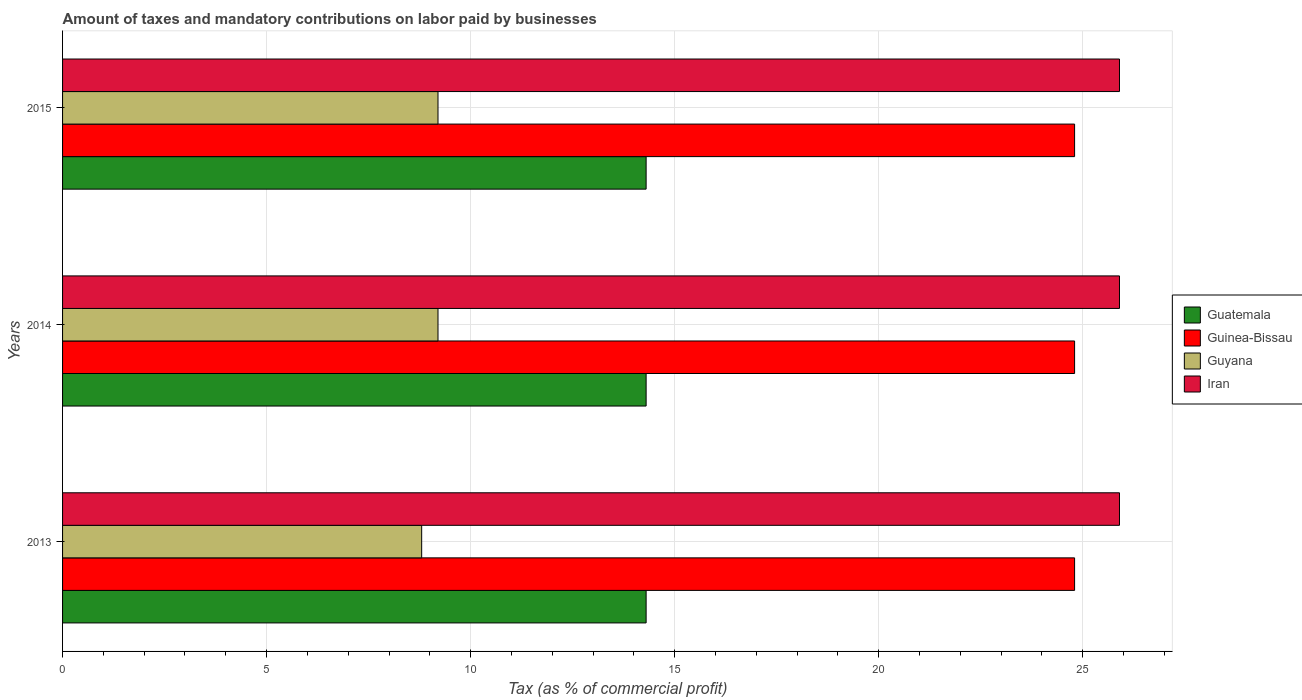Are the number of bars per tick equal to the number of legend labels?
Provide a succinct answer. Yes. How many bars are there on the 2nd tick from the top?
Ensure brevity in your answer.  4. What is the label of the 1st group of bars from the top?
Make the answer very short. 2015. Across all years, what is the maximum percentage of taxes paid by businesses in Guinea-Bissau?
Provide a succinct answer. 24.8. Across all years, what is the minimum percentage of taxes paid by businesses in Guinea-Bissau?
Offer a very short reply. 24.8. In which year was the percentage of taxes paid by businesses in Guyana minimum?
Make the answer very short. 2013. What is the total percentage of taxes paid by businesses in Iran in the graph?
Ensure brevity in your answer.  77.7. What is the difference between the percentage of taxes paid by businesses in Guinea-Bissau in 2014 and that in 2015?
Give a very brief answer. 0. What is the difference between the percentage of taxes paid by businesses in Guyana in 2013 and the percentage of taxes paid by businesses in Guinea-Bissau in 2015?
Make the answer very short. -16. What is the average percentage of taxes paid by businesses in Guinea-Bissau per year?
Your response must be concise. 24.8. In the year 2013, what is the difference between the percentage of taxes paid by businesses in Guatemala and percentage of taxes paid by businesses in Iran?
Your answer should be very brief. -11.6. What is the ratio of the percentage of taxes paid by businesses in Guyana in 2013 to that in 2014?
Keep it short and to the point. 0.96. Is the percentage of taxes paid by businesses in Guyana in 2013 less than that in 2014?
Provide a succinct answer. Yes. What is the difference between the highest and the second highest percentage of taxes paid by businesses in Guatemala?
Your answer should be very brief. 0. In how many years, is the percentage of taxes paid by businesses in Guinea-Bissau greater than the average percentage of taxes paid by businesses in Guinea-Bissau taken over all years?
Provide a short and direct response. 0. What does the 3rd bar from the top in 2013 represents?
Make the answer very short. Guinea-Bissau. What does the 3rd bar from the bottom in 2013 represents?
Provide a succinct answer. Guyana. How many bars are there?
Ensure brevity in your answer.  12. Are all the bars in the graph horizontal?
Your answer should be compact. Yes. Are the values on the major ticks of X-axis written in scientific E-notation?
Your response must be concise. No. How many legend labels are there?
Offer a terse response. 4. What is the title of the graph?
Offer a terse response. Amount of taxes and mandatory contributions on labor paid by businesses. What is the label or title of the X-axis?
Provide a succinct answer. Tax (as % of commercial profit). What is the Tax (as % of commercial profit) of Guatemala in 2013?
Your response must be concise. 14.3. What is the Tax (as % of commercial profit) in Guinea-Bissau in 2013?
Give a very brief answer. 24.8. What is the Tax (as % of commercial profit) in Guyana in 2013?
Provide a short and direct response. 8.8. What is the Tax (as % of commercial profit) of Iran in 2013?
Your response must be concise. 25.9. What is the Tax (as % of commercial profit) of Guatemala in 2014?
Ensure brevity in your answer.  14.3. What is the Tax (as % of commercial profit) of Guinea-Bissau in 2014?
Offer a terse response. 24.8. What is the Tax (as % of commercial profit) of Guyana in 2014?
Make the answer very short. 9.2. What is the Tax (as % of commercial profit) in Iran in 2014?
Give a very brief answer. 25.9. What is the Tax (as % of commercial profit) of Guinea-Bissau in 2015?
Your response must be concise. 24.8. What is the Tax (as % of commercial profit) in Guyana in 2015?
Give a very brief answer. 9.2. What is the Tax (as % of commercial profit) of Iran in 2015?
Your response must be concise. 25.9. Across all years, what is the maximum Tax (as % of commercial profit) in Guinea-Bissau?
Offer a very short reply. 24.8. Across all years, what is the maximum Tax (as % of commercial profit) in Guyana?
Your answer should be compact. 9.2. Across all years, what is the maximum Tax (as % of commercial profit) in Iran?
Provide a short and direct response. 25.9. Across all years, what is the minimum Tax (as % of commercial profit) of Guinea-Bissau?
Offer a very short reply. 24.8. Across all years, what is the minimum Tax (as % of commercial profit) in Iran?
Provide a succinct answer. 25.9. What is the total Tax (as % of commercial profit) of Guatemala in the graph?
Offer a terse response. 42.9. What is the total Tax (as % of commercial profit) of Guinea-Bissau in the graph?
Keep it short and to the point. 74.4. What is the total Tax (as % of commercial profit) of Guyana in the graph?
Make the answer very short. 27.2. What is the total Tax (as % of commercial profit) of Iran in the graph?
Your answer should be very brief. 77.7. What is the difference between the Tax (as % of commercial profit) in Guinea-Bissau in 2013 and that in 2014?
Provide a short and direct response. 0. What is the difference between the Tax (as % of commercial profit) in Iran in 2013 and that in 2014?
Keep it short and to the point. 0. What is the difference between the Tax (as % of commercial profit) in Guatemala in 2013 and that in 2015?
Make the answer very short. 0. What is the difference between the Tax (as % of commercial profit) of Iran in 2013 and that in 2015?
Provide a short and direct response. 0. What is the difference between the Tax (as % of commercial profit) of Guatemala in 2014 and that in 2015?
Offer a terse response. 0. What is the difference between the Tax (as % of commercial profit) in Guyana in 2014 and that in 2015?
Give a very brief answer. 0. What is the difference between the Tax (as % of commercial profit) in Guinea-Bissau in 2013 and the Tax (as % of commercial profit) in Iran in 2014?
Provide a succinct answer. -1.1. What is the difference between the Tax (as % of commercial profit) in Guyana in 2013 and the Tax (as % of commercial profit) in Iran in 2014?
Give a very brief answer. -17.1. What is the difference between the Tax (as % of commercial profit) in Guatemala in 2013 and the Tax (as % of commercial profit) in Guinea-Bissau in 2015?
Your response must be concise. -10.5. What is the difference between the Tax (as % of commercial profit) of Guinea-Bissau in 2013 and the Tax (as % of commercial profit) of Guyana in 2015?
Your answer should be very brief. 15.6. What is the difference between the Tax (as % of commercial profit) in Guyana in 2013 and the Tax (as % of commercial profit) in Iran in 2015?
Your answer should be compact. -17.1. What is the difference between the Tax (as % of commercial profit) in Guatemala in 2014 and the Tax (as % of commercial profit) in Iran in 2015?
Your response must be concise. -11.6. What is the difference between the Tax (as % of commercial profit) in Guinea-Bissau in 2014 and the Tax (as % of commercial profit) in Iran in 2015?
Offer a terse response. -1.1. What is the difference between the Tax (as % of commercial profit) of Guyana in 2014 and the Tax (as % of commercial profit) of Iran in 2015?
Make the answer very short. -16.7. What is the average Tax (as % of commercial profit) of Guinea-Bissau per year?
Offer a terse response. 24.8. What is the average Tax (as % of commercial profit) of Guyana per year?
Your answer should be very brief. 9.07. What is the average Tax (as % of commercial profit) of Iran per year?
Provide a short and direct response. 25.9. In the year 2013, what is the difference between the Tax (as % of commercial profit) of Guatemala and Tax (as % of commercial profit) of Guinea-Bissau?
Give a very brief answer. -10.5. In the year 2013, what is the difference between the Tax (as % of commercial profit) in Guinea-Bissau and Tax (as % of commercial profit) in Iran?
Your response must be concise. -1.1. In the year 2013, what is the difference between the Tax (as % of commercial profit) in Guyana and Tax (as % of commercial profit) in Iran?
Your response must be concise. -17.1. In the year 2014, what is the difference between the Tax (as % of commercial profit) in Guatemala and Tax (as % of commercial profit) in Guinea-Bissau?
Give a very brief answer. -10.5. In the year 2014, what is the difference between the Tax (as % of commercial profit) of Guinea-Bissau and Tax (as % of commercial profit) of Guyana?
Ensure brevity in your answer.  15.6. In the year 2014, what is the difference between the Tax (as % of commercial profit) in Guyana and Tax (as % of commercial profit) in Iran?
Provide a short and direct response. -16.7. In the year 2015, what is the difference between the Tax (as % of commercial profit) in Guatemala and Tax (as % of commercial profit) in Guinea-Bissau?
Provide a succinct answer. -10.5. In the year 2015, what is the difference between the Tax (as % of commercial profit) in Guatemala and Tax (as % of commercial profit) in Guyana?
Make the answer very short. 5.1. In the year 2015, what is the difference between the Tax (as % of commercial profit) of Guatemala and Tax (as % of commercial profit) of Iran?
Ensure brevity in your answer.  -11.6. In the year 2015, what is the difference between the Tax (as % of commercial profit) in Guyana and Tax (as % of commercial profit) in Iran?
Offer a very short reply. -16.7. What is the ratio of the Tax (as % of commercial profit) in Guatemala in 2013 to that in 2014?
Ensure brevity in your answer.  1. What is the ratio of the Tax (as % of commercial profit) of Guyana in 2013 to that in 2014?
Your answer should be very brief. 0.96. What is the ratio of the Tax (as % of commercial profit) of Guinea-Bissau in 2013 to that in 2015?
Your response must be concise. 1. What is the ratio of the Tax (as % of commercial profit) in Guyana in 2013 to that in 2015?
Offer a terse response. 0.96. What is the ratio of the Tax (as % of commercial profit) in Iran in 2013 to that in 2015?
Give a very brief answer. 1. What is the ratio of the Tax (as % of commercial profit) of Guyana in 2014 to that in 2015?
Offer a terse response. 1. What is the difference between the highest and the second highest Tax (as % of commercial profit) of Guatemala?
Provide a succinct answer. 0. What is the difference between the highest and the second highest Tax (as % of commercial profit) in Guinea-Bissau?
Provide a short and direct response. 0. What is the difference between the highest and the second highest Tax (as % of commercial profit) in Guyana?
Your response must be concise. 0. What is the difference between the highest and the lowest Tax (as % of commercial profit) of Guatemala?
Make the answer very short. 0. What is the difference between the highest and the lowest Tax (as % of commercial profit) in Guyana?
Offer a very short reply. 0.4. 